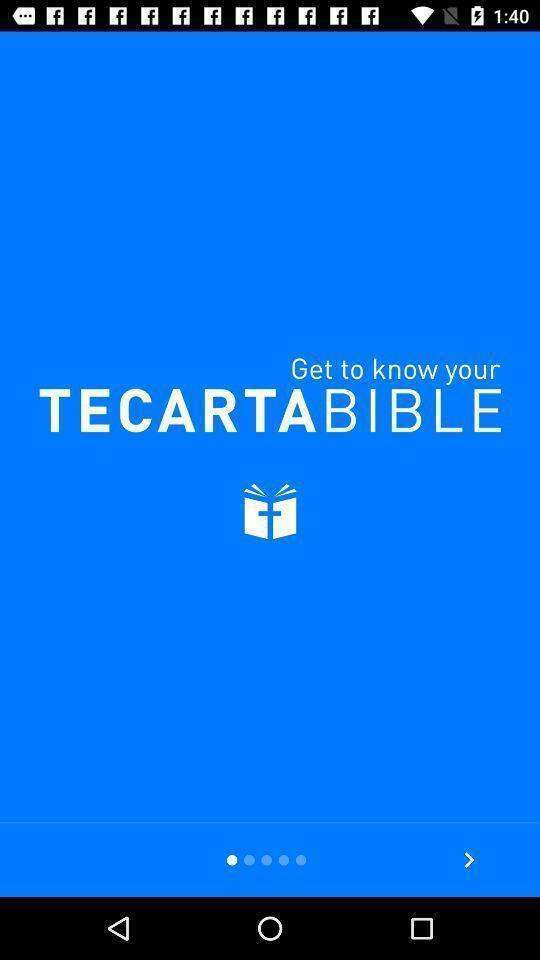Explain what's happening in this screen capture. Welcome page. 